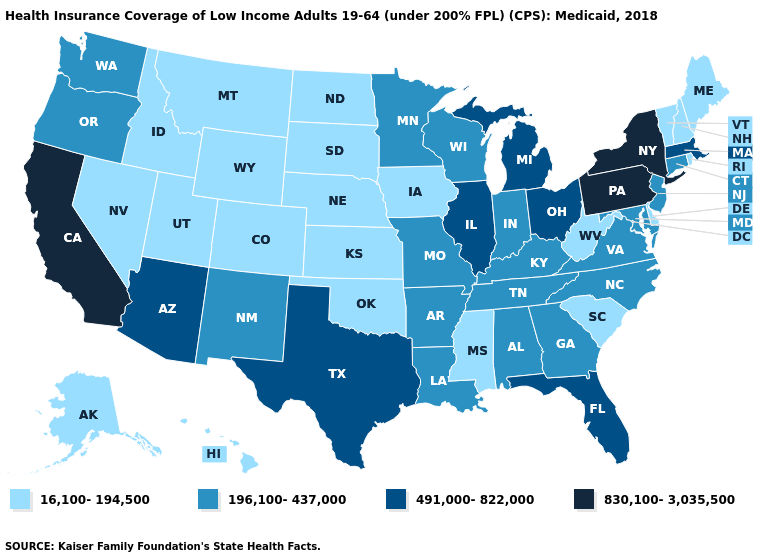Does the map have missing data?
Give a very brief answer. No. What is the lowest value in the Northeast?
Be succinct. 16,100-194,500. Does Washington have a lower value than New Hampshire?
Answer briefly. No. Name the states that have a value in the range 16,100-194,500?
Quick response, please. Alaska, Colorado, Delaware, Hawaii, Idaho, Iowa, Kansas, Maine, Mississippi, Montana, Nebraska, Nevada, New Hampshire, North Dakota, Oklahoma, Rhode Island, South Carolina, South Dakota, Utah, Vermont, West Virginia, Wyoming. Name the states that have a value in the range 830,100-3,035,500?
Short answer required. California, New York, Pennsylvania. Which states have the lowest value in the Northeast?
Be succinct. Maine, New Hampshire, Rhode Island, Vermont. Which states have the lowest value in the West?
Be succinct. Alaska, Colorado, Hawaii, Idaho, Montana, Nevada, Utah, Wyoming. Name the states that have a value in the range 196,100-437,000?
Be succinct. Alabama, Arkansas, Connecticut, Georgia, Indiana, Kentucky, Louisiana, Maryland, Minnesota, Missouri, New Jersey, New Mexico, North Carolina, Oregon, Tennessee, Virginia, Washington, Wisconsin. Name the states that have a value in the range 830,100-3,035,500?
Short answer required. California, New York, Pennsylvania. Name the states that have a value in the range 491,000-822,000?
Keep it brief. Arizona, Florida, Illinois, Massachusetts, Michigan, Ohio, Texas. Name the states that have a value in the range 16,100-194,500?
Quick response, please. Alaska, Colorado, Delaware, Hawaii, Idaho, Iowa, Kansas, Maine, Mississippi, Montana, Nebraska, Nevada, New Hampshire, North Dakota, Oklahoma, Rhode Island, South Carolina, South Dakota, Utah, Vermont, West Virginia, Wyoming. What is the value of Utah?
Be succinct. 16,100-194,500. Among the states that border Idaho , does Montana have the highest value?
Keep it brief. No. Does Nebraska have the highest value in the MidWest?
Give a very brief answer. No. Which states have the highest value in the USA?
Write a very short answer. California, New York, Pennsylvania. 